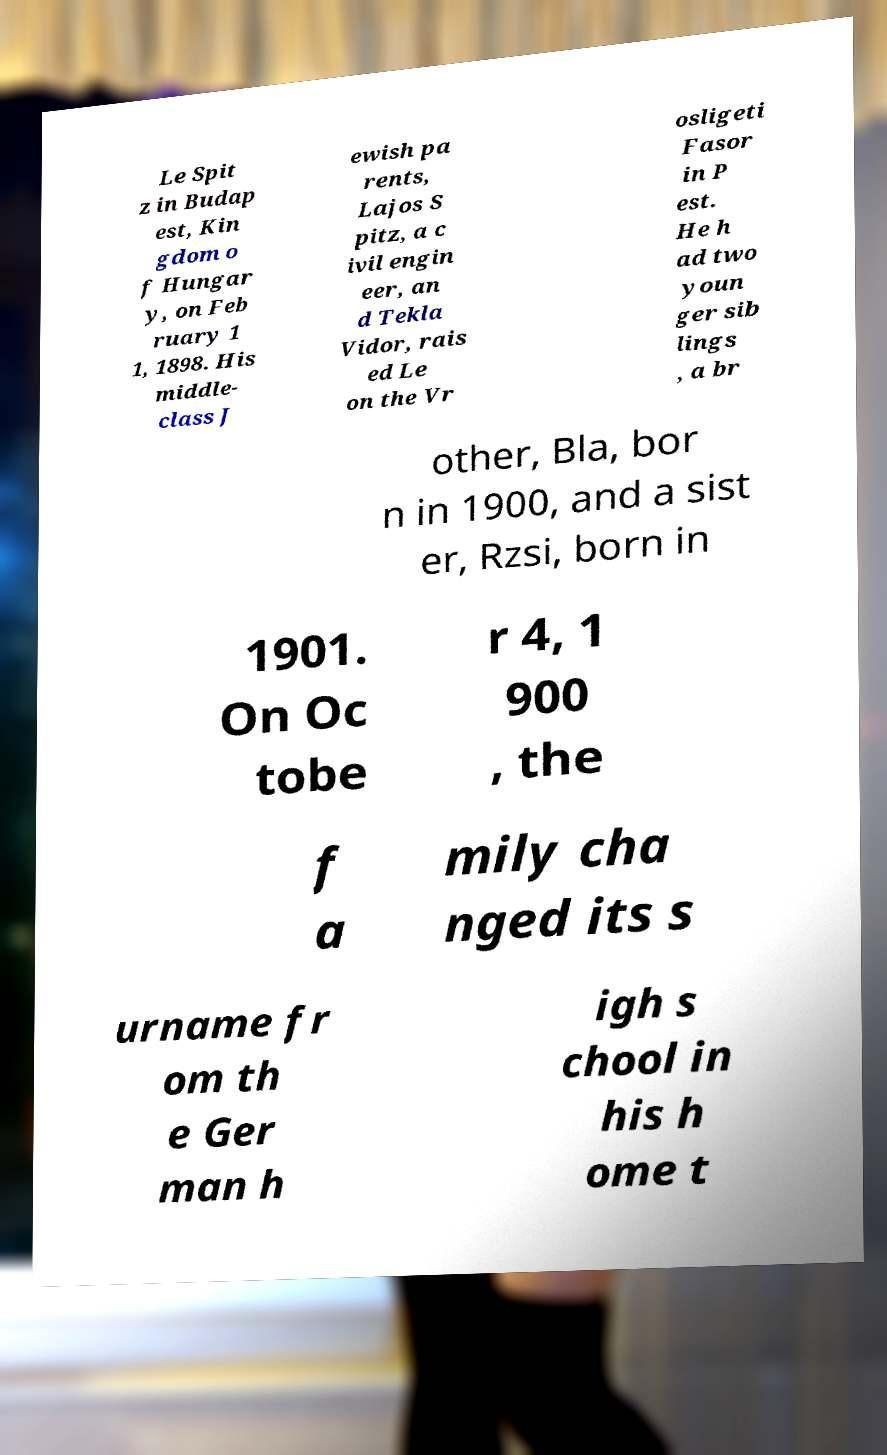For documentation purposes, I need the text within this image transcribed. Could you provide that? Le Spit z in Budap est, Kin gdom o f Hungar y, on Feb ruary 1 1, 1898. His middle- class J ewish pa rents, Lajos S pitz, a c ivil engin eer, an d Tekla Vidor, rais ed Le on the Vr osligeti Fasor in P est. He h ad two youn ger sib lings , a br other, Bla, bor n in 1900, and a sist er, Rzsi, born in 1901. On Oc tobe r 4, 1 900 , the f a mily cha nged its s urname fr om th e Ger man h igh s chool in his h ome t 